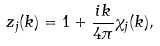Convert formula to latex. <formula><loc_0><loc_0><loc_500><loc_500>z _ { j } ( k ) = 1 + \frac { i k } { 4 \pi } \chi _ { j } ( k ) ,</formula> 